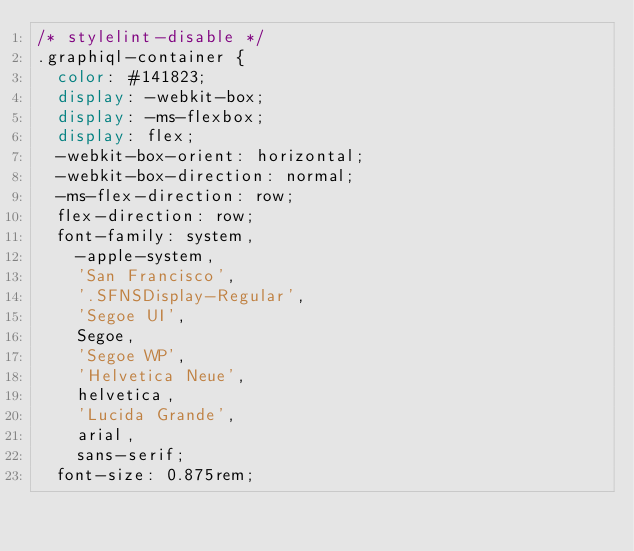<code> <loc_0><loc_0><loc_500><loc_500><_CSS_>/* stylelint-disable */
.graphiql-container {
  color: #141823;
  display: -webkit-box;
  display: -ms-flexbox;
  display: flex;
  -webkit-box-orient: horizontal;
  -webkit-box-direction: normal;
  -ms-flex-direction: row;
  flex-direction: row;
  font-family: system,
    -apple-system,
    'San Francisco',
    '.SFNSDisplay-Regular',
    'Segoe UI',
    Segoe,
    'Segoe WP',
    'Helvetica Neue',
    helvetica,
    'Lucida Grande',
    arial,
    sans-serif;
  font-size: 0.875rem;</code> 